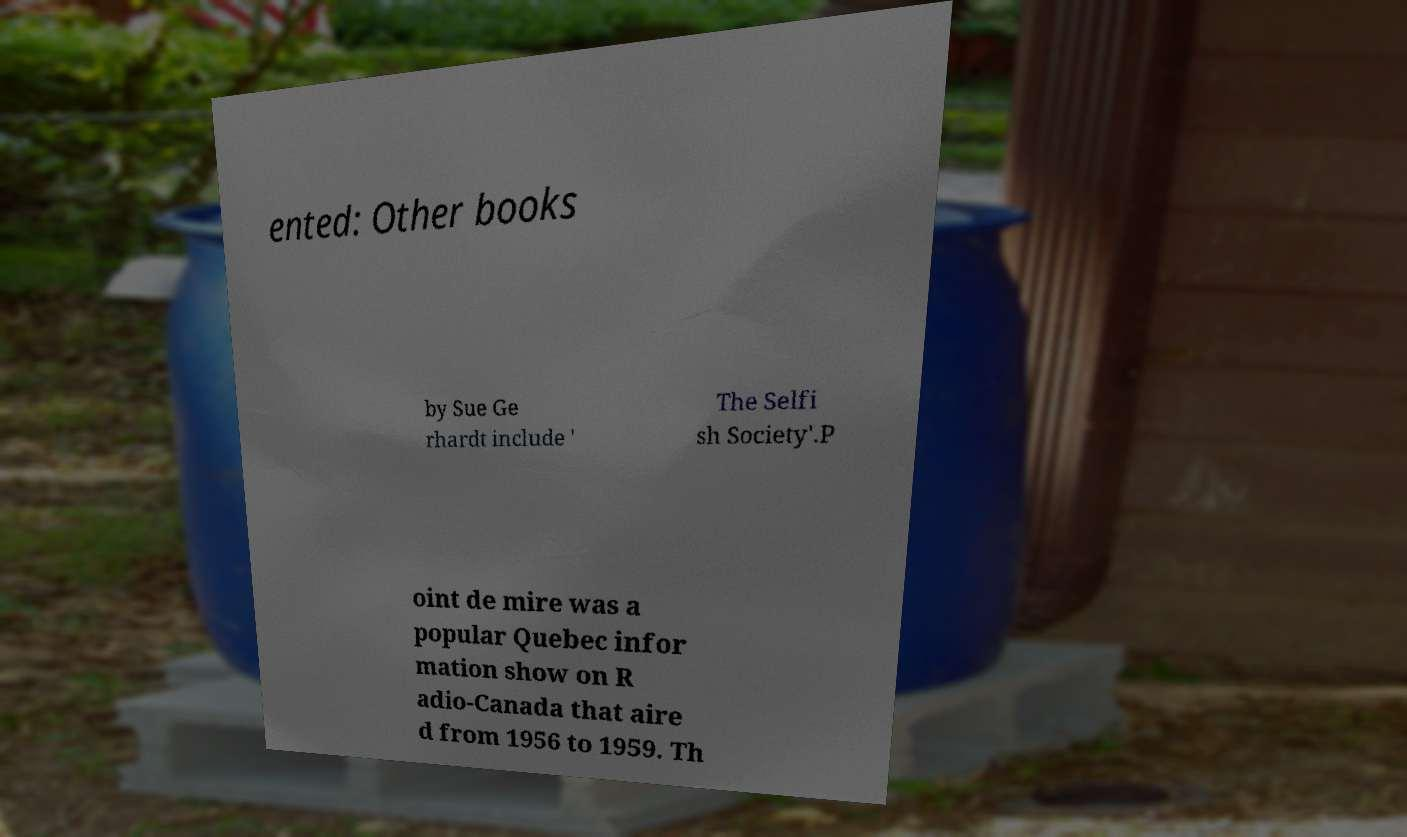What messages or text are displayed in this image? I need them in a readable, typed format. ented: Other books by Sue Ge rhardt include ' The Selfi sh Society'.P oint de mire was a popular Quebec infor mation show on R adio-Canada that aire d from 1956 to 1959. Th 